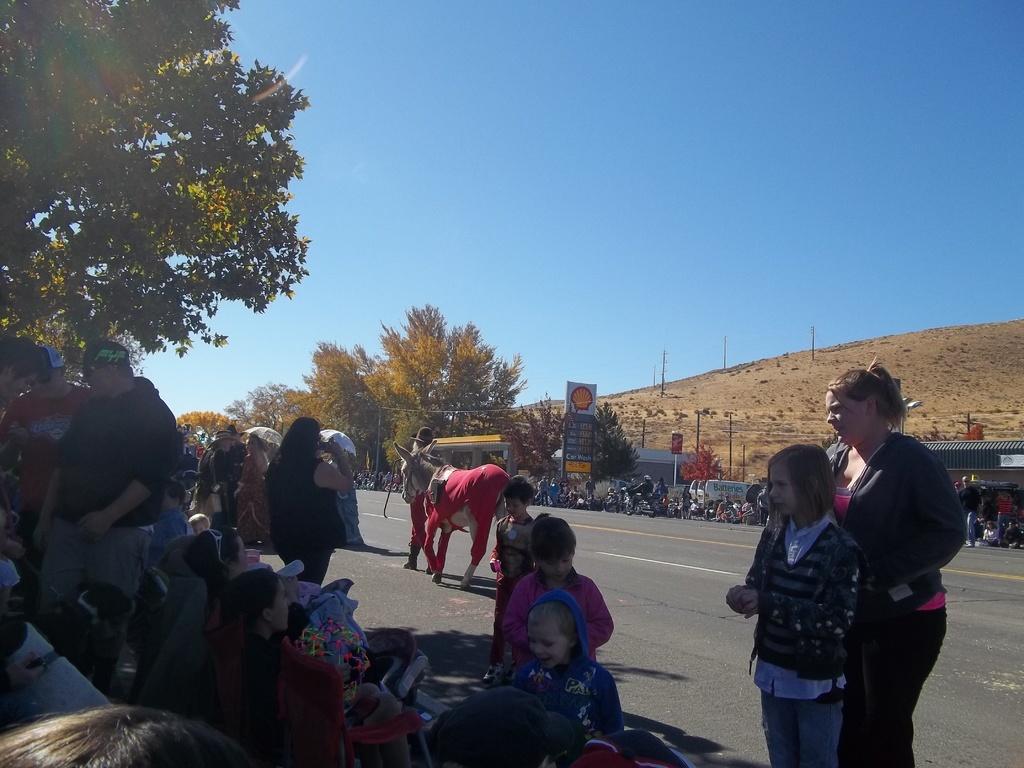Can you describe this image briefly? In this picture we can see a group of people and a horse on the road, here we can see sheds, umbrellas, trees, poles, motorcycles and some objects and we can see sky in the background. 